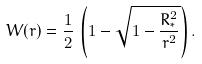<formula> <loc_0><loc_0><loc_500><loc_500>W ( r ) = \frac { 1 } { 2 } \, \left ( 1 - \sqrt { 1 - \frac { R _ { * } ^ { 2 } } { r ^ { 2 } } } \right ) .</formula> 